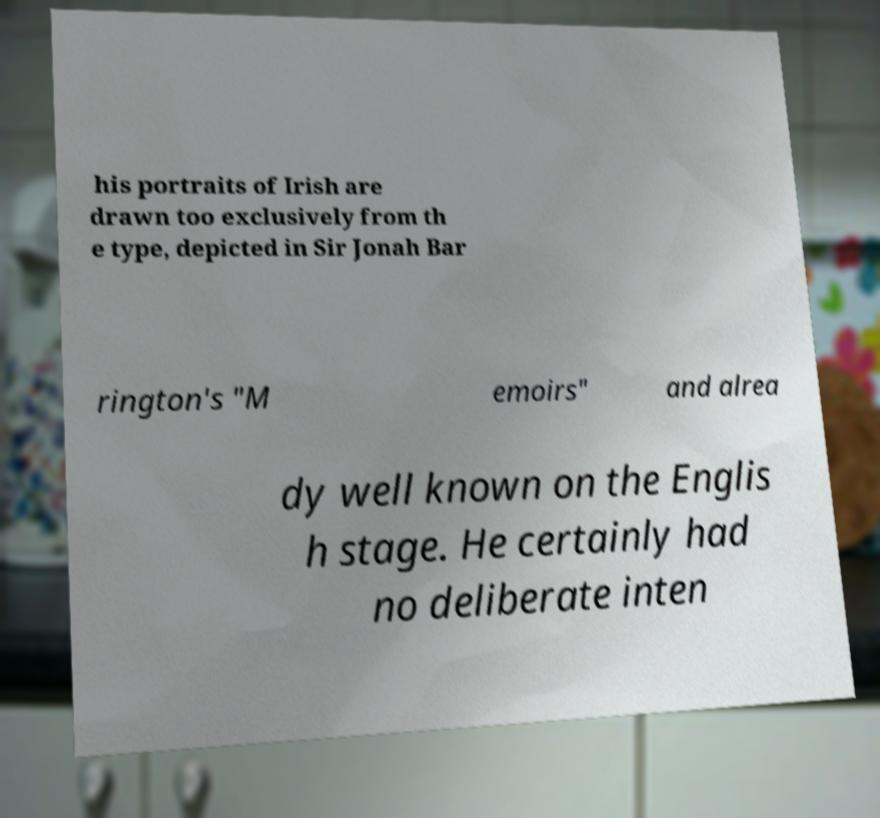What messages or text are displayed in this image? I need them in a readable, typed format. his portraits of Irish are drawn too exclusively from th e type, depicted in Sir Jonah Bar rington's "M emoirs" and alrea dy well known on the Englis h stage. He certainly had no deliberate inten 